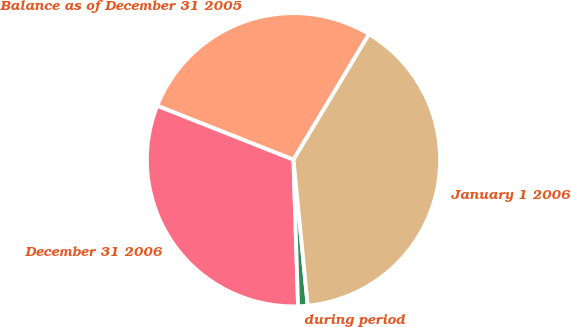Convert chart to OTSL. <chart><loc_0><loc_0><loc_500><loc_500><pie_chart><fcel>Balance as of December 31 2005<fcel>December 31 2006<fcel>during period<fcel>January 1 2006<nl><fcel>27.62%<fcel>31.5%<fcel>1.05%<fcel>39.84%<nl></chart> 